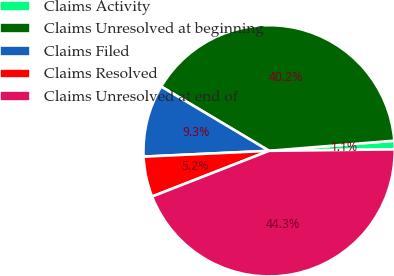<chart> <loc_0><loc_0><loc_500><loc_500><pie_chart><fcel>Claims Activity<fcel>Claims Unresolved at beginning<fcel>Claims Filed<fcel>Claims Resolved<fcel>Claims Unresolved at end of<nl><fcel>1.1%<fcel>40.16%<fcel>9.29%<fcel>5.19%<fcel>44.25%<nl></chart> 